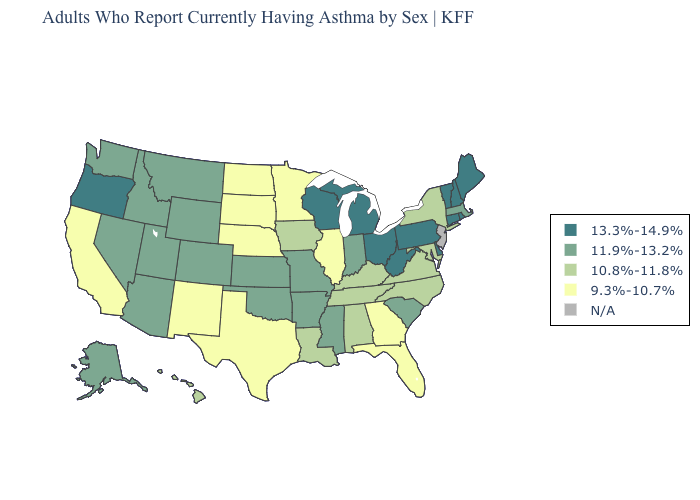Name the states that have a value in the range 13.3%-14.9%?
Quick response, please. Connecticut, Delaware, Maine, Michigan, New Hampshire, Ohio, Oregon, Pennsylvania, Rhode Island, Vermont, West Virginia, Wisconsin. Name the states that have a value in the range 10.8%-11.8%?
Give a very brief answer. Alabama, Hawaii, Iowa, Kentucky, Louisiana, Maryland, New York, North Carolina, Tennessee, Virginia. Among the states that border Georgia , which have the highest value?
Concise answer only. South Carolina. Does Kentucky have the highest value in the USA?
Answer briefly. No. What is the value of Mississippi?
Short answer required. 11.9%-13.2%. Does West Virginia have the highest value in the USA?
Short answer required. Yes. Name the states that have a value in the range N/A?
Be succinct. New Jersey. Name the states that have a value in the range 10.8%-11.8%?
Answer briefly. Alabama, Hawaii, Iowa, Kentucky, Louisiana, Maryland, New York, North Carolina, Tennessee, Virginia. Does Delaware have the highest value in the USA?
Write a very short answer. Yes. What is the value of New Jersey?
Answer briefly. N/A. Among the states that border North Dakota , does Minnesota have the lowest value?
Quick response, please. Yes. What is the value of North Dakota?
Give a very brief answer. 9.3%-10.7%. Does Wisconsin have the highest value in the USA?
Concise answer only. Yes. What is the value of Kansas?
Keep it brief. 11.9%-13.2%. What is the value of Indiana?
Quick response, please. 11.9%-13.2%. 